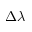Convert formula to latex. <formula><loc_0><loc_0><loc_500><loc_500>\Delta \lambda</formula> 